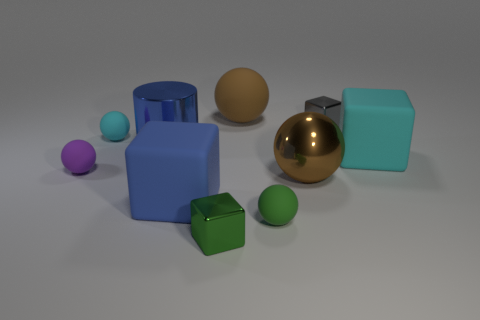How many objects in the image have a spherical shape? There are three objects with a spherical shape in the image: a small purple sphere, a medium green sphere, and a large shiny gold sphere. 